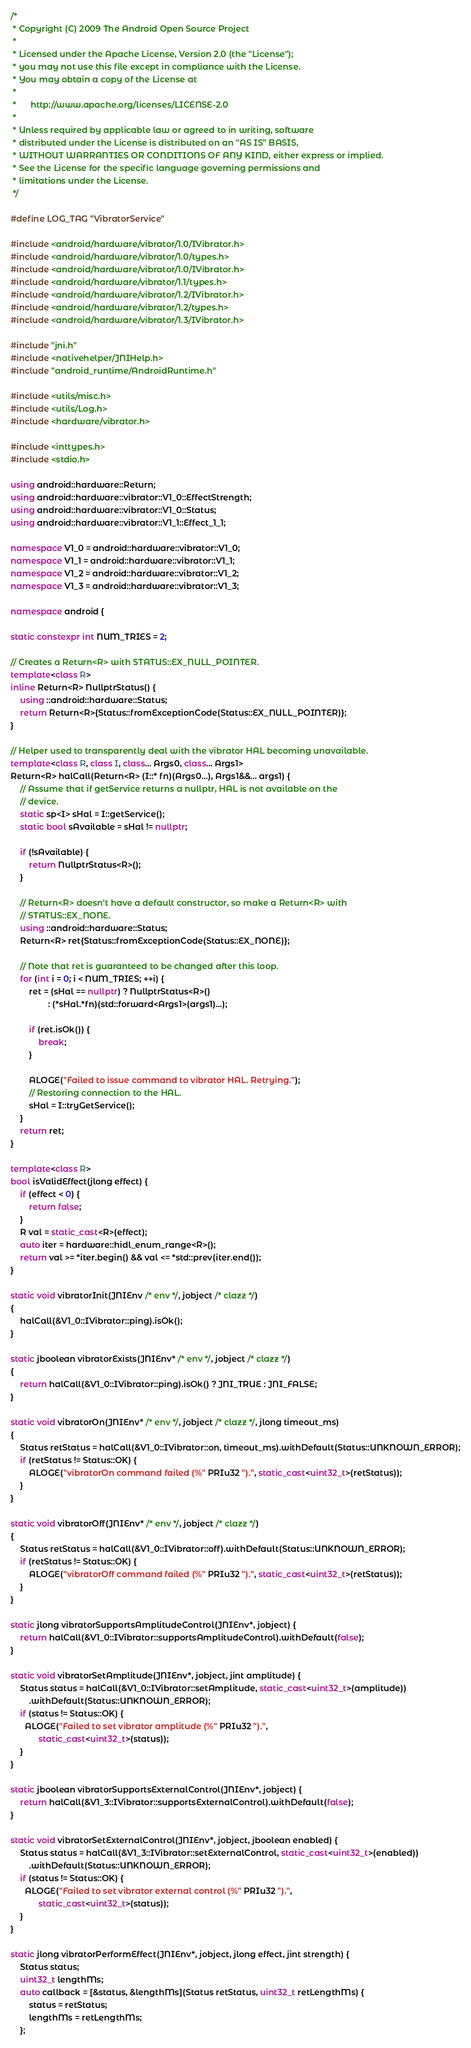Convert code to text. <code><loc_0><loc_0><loc_500><loc_500><_C++_>/*
 * Copyright (C) 2009 The Android Open Source Project
 *
 * Licensed under the Apache License, Version 2.0 (the "License");
 * you may not use this file except in compliance with the License.
 * You may obtain a copy of the License at
 *
 *      http://www.apache.org/licenses/LICENSE-2.0
 *
 * Unless required by applicable law or agreed to in writing, software
 * distributed under the License is distributed on an "AS IS" BASIS,
 * WITHOUT WARRANTIES OR CONDITIONS OF ANY KIND, either express or implied.
 * See the License for the specific language governing permissions and
 * limitations under the License.
 */

#define LOG_TAG "VibratorService"

#include <android/hardware/vibrator/1.0/IVibrator.h>
#include <android/hardware/vibrator/1.0/types.h>
#include <android/hardware/vibrator/1.0/IVibrator.h>
#include <android/hardware/vibrator/1.1/types.h>
#include <android/hardware/vibrator/1.2/IVibrator.h>
#include <android/hardware/vibrator/1.2/types.h>
#include <android/hardware/vibrator/1.3/IVibrator.h>

#include "jni.h"
#include <nativehelper/JNIHelp.h>
#include "android_runtime/AndroidRuntime.h"

#include <utils/misc.h>
#include <utils/Log.h>
#include <hardware/vibrator.h>

#include <inttypes.h>
#include <stdio.h>

using android::hardware::Return;
using android::hardware::vibrator::V1_0::EffectStrength;
using android::hardware::vibrator::V1_0::Status;
using android::hardware::vibrator::V1_1::Effect_1_1;

namespace V1_0 = android::hardware::vibrator::V1_0;
namespace V1_1 = android::hardware::vibrator::V1_1;
namespace V1_2 = android::hardware::vibrator::V1_2;
namespace V1_3 = android::hardware::vibrator::V1_3;

namespace android {

static constexpr int NUM_TRIES = 2;

// Creates a Return<R> with STATUS::EX_NULL_POINTER.
template<class R>
inline Return<R> NullptrStatus() {
    using ::android::hardware::Status;
    return Return<R>{Status::fromExceptionCode(Status::EX_NULL_POINTER)};
}

// Helper used to transparently deal with the vibrator HAL becoming unavailable.
template<class R, class I, class... Args0, class... Args1>
Return<R> halCall(Return<R> (I::* fn)(Args0...), Args1&&... args1) {
    // Assume that if getService returns a nullptr, HAL is not available on the
    // device.
    static sp<I> sHal = I::getService();
    static bool sAvailable = sHal != nullptr;

    if (!sAvailable) {
        return NullptrStatus<R>();
    }

    // Return<R> doesn't have a default constructor, so make a Return<R> with
    // STATUS::EX_NONE.
    using ::android::hardware::Status;
    Return<R> ret{Status::fromExceptionCode(Status::EX_NONE)};

    // Note that ret is guaranteed to be changed after this loop.
    for (int i = 0; i < NUM_TRIES; ++i) {
        ret = (sHal == nullptr) ? NullptrStatus<R>()
                : (*sHal.*fn)(std::forward<Args1>(args1)...);

        if (ret.isOk()) {
            break;
        }

        ALOGE("Failed to issue command to vibrator HAL. Retrying.");
        // Restoring connection to the HAL.
        sHal = I::tryGetService();
    }
    return ret;
}

template<class R>
bool isValidEffect(jlong effect) {
    if (effect < 0) {
        return false;
    }
    R val = static_cast<R>(effect);
    auto iter = hardware::hidl_enum_range<R>();
    return val >= *iter.begin() && val <= *std::prev(iter.end());
}

static void vibratorInit(JNIEnv /* env */, jobject /* clazz */)
{
    halCall(&V1_0::IVibrator::ping).isOk();
}

static jboolean vibratorExists(JNIEnv* /* env */, jobject /* clazz */)
{
    return halCall(&V1_0::IVibrator::ping).isOk() ? JNI_TRUE : JNI_FALSE;
}

static void vibratorOn(JNIEnv* /* env */, jobject /* clazz */, jlong timeout_ms)
{
    Status retStatus = halCall(&V1_0::IVibrator::on, timeout_ms).withDefault(Status::UNKNOWN_ERROR);
    if (retStatus != Status::OK) {
        ALOGE("vibratorOn command failed (%" PRIu32 ").", static_cast<uint32_t>(retStatus));
    }
}

static void vibratorOff(JNIEnv* /* env */, jobject /* clazz */)
{
    Status retStatus = halCall(&V1_0::IVibrator::off).withDefault(Status::UNKNOWN_ERROR);
    if (retStatus != Status::OK) {
        ALOGE("vibratorOff command failed (%" PRIu32 ").", static_cast<uint32_t>(retStatus));
    }
}

static jlong vibratorSupportsAmplitudeControl(JNIEnv*, jobject) {
    return halCall(&V1_0::IVibrator::supportsAmplitudeControl).withDefault(false);
}

static void vibratorSetAmplitude(JNIEnv*, jobject, jint amplitude) {
    Status status = halCall(&V1_0::IVibrator::setAmplitude, static_cast<uint32_t>(amplitude))
        .withDefault(Status::UNKNOWN_ERROR);
    if (status != Status::OK) {
      ALOGE("Failed to set vibrator amplitude (%" PRIu32 ").",
            static_cast<uint32_t>(status));
    }
}

static jboolean vibratorSupportsExternalControl(JNIEnv*, jobject) {
    return halCall(&V1_3::IVibrator::supportsExternalControl).withDefault(false);
}

static void vibratorSetExternalControl(JNIEnv*, jobject, jboolean enabled) {
    Status status = halCall(&V1_3::IVibrator::setExternalControl, static_cast<uint32_t>(enabled))
        .withDefault(Status::UNKNOWN_ERROR);
    if (status != Status::OK) {
      ALOGE("Failed to set vibrator external control (%" PRIu32 ").",
            static_cast<uint32_t>(status));
    }
}

static jlong vibratorPerformEffect(JNIEnv*, jobject, jlong effect, jint strength) {
    Status status;
    uint32_t lengthMs;
    auto callback = [&status, &lengthMs](Status retStatus, uint32_t retLengthMs) {
        status = retStatus;
        lengthMs = retLengthMs;
    };</code> 